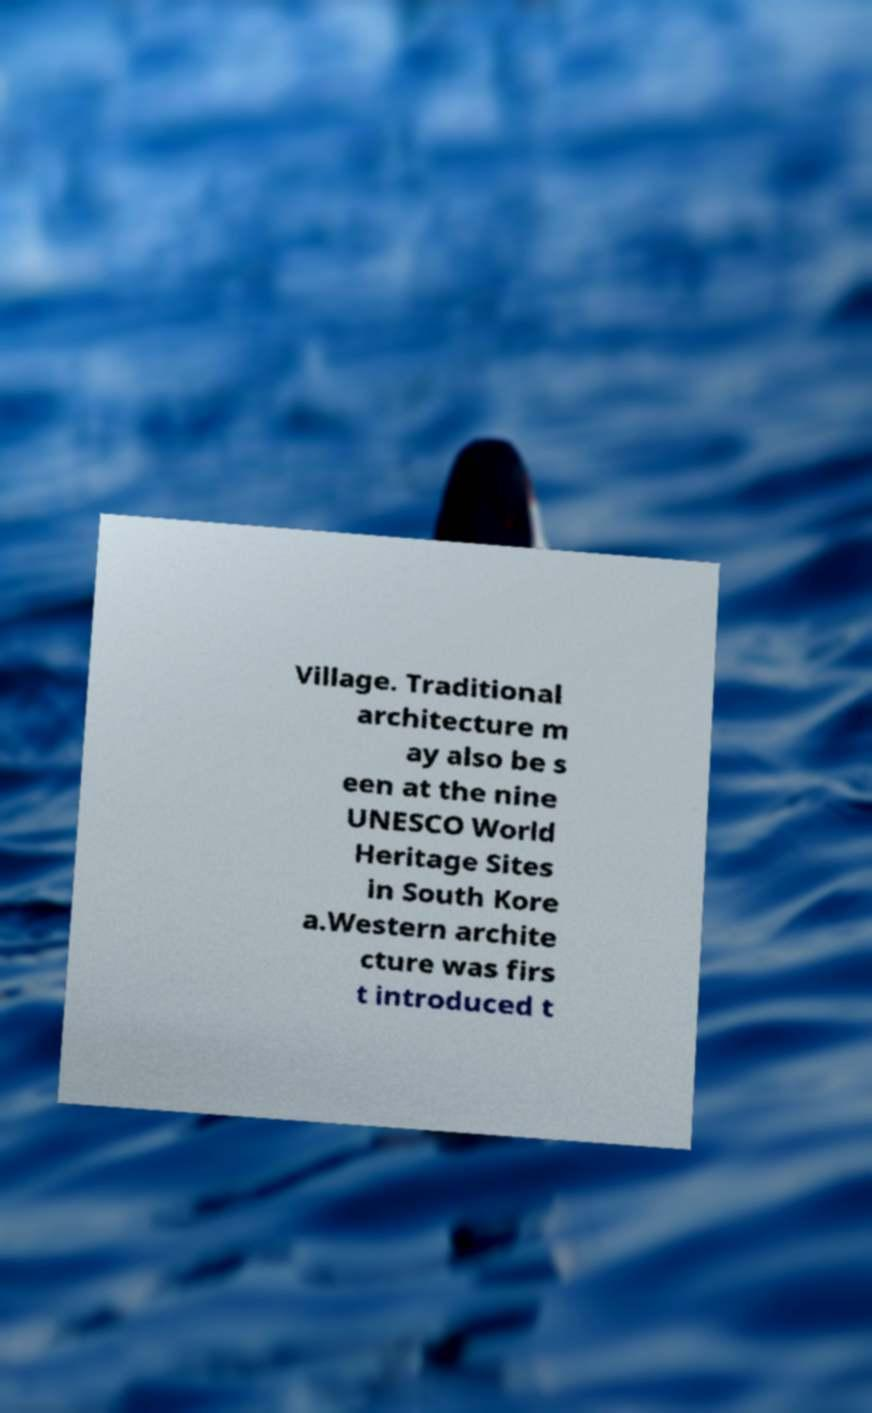Could you assist in decoding the text presented in this image and type it out clearly? Village. Traditional architecture m ay also be s een at the nine UNESCO World Heritage Sites in South Kore a.Western archite cture was firs t introduced t 